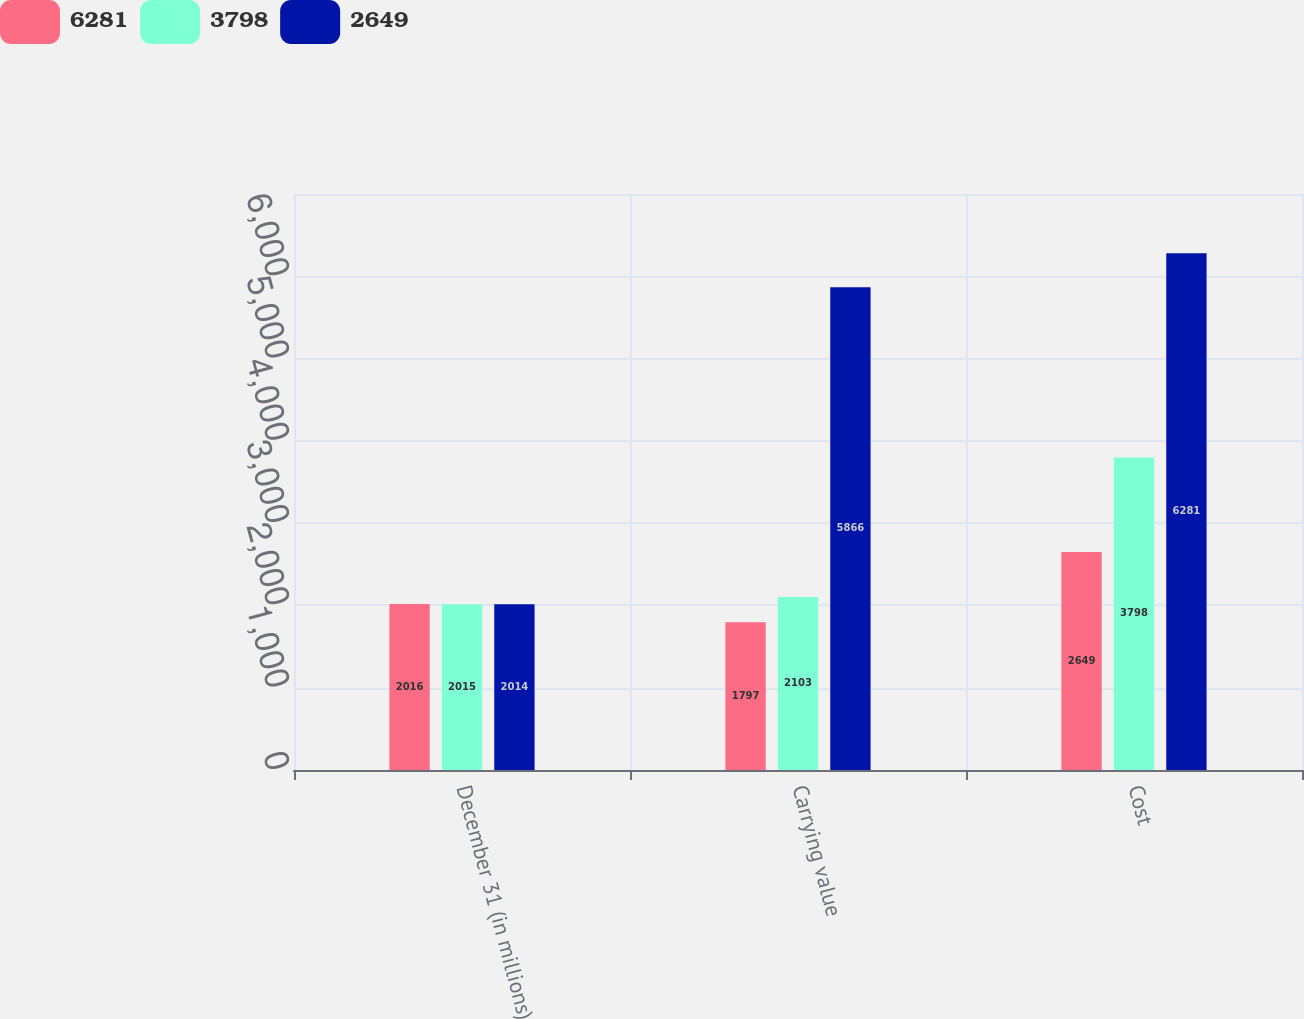Convert chart. <chart><loc_0><loc_0><loc_500><loc_500><stacked_bar_chart><ecel><fcel>December 31 (in millions)<fcel>Carrying value<fcel>Cost<nl><fcel>6281<fcel>2016<fcel>1797<fcel>2649<nl><fcel>3798<fcel>2015<fcel>2103<fcel>3798<nl><fcel>2649<fcel>2014<fcel>5866<fcel>6281<nl></chart> 